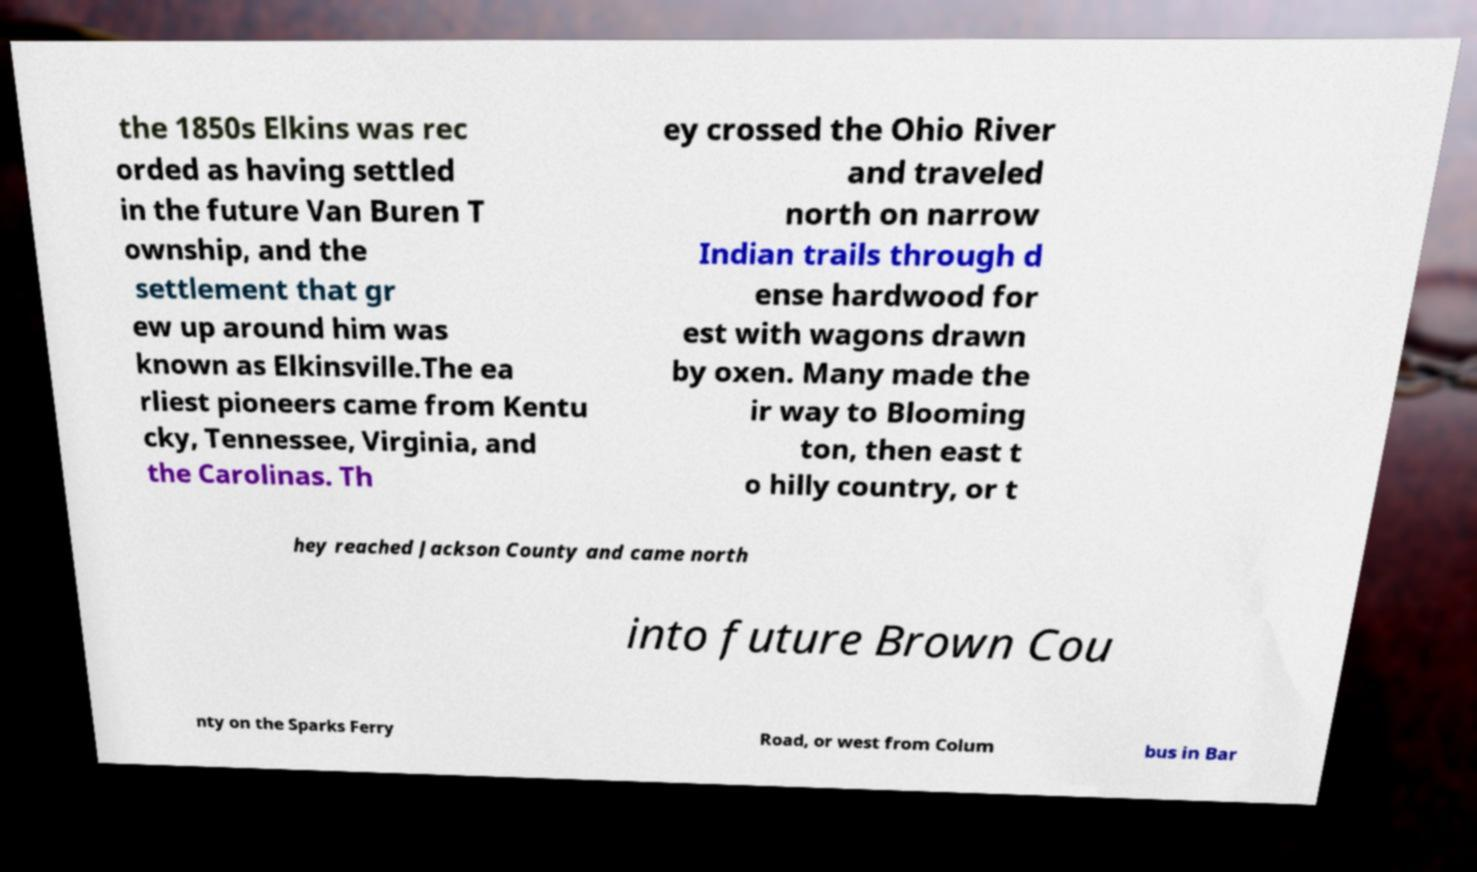Could you extract and type out the text from this image? the 1850s Elkins was rec orded as having settled in the future Van Buren T ownship, and the settlement that gr ew up around him was known as Elkinsville.The ea rliest pioneers came from Kentu cky, Tennessee, Virginia, and the Carolinas. Th ey crossed the Ohio River and traveled north on narrow Indian trails through d ense hardwood for est with wagons drawn by oxen. Many made the ir way to Blooming ton, then east t o hilly country, or t hey reached Jackson County and came north into future Brown Cou nty on the Sparks Ferry Road, or west from Colum bus in Bar 